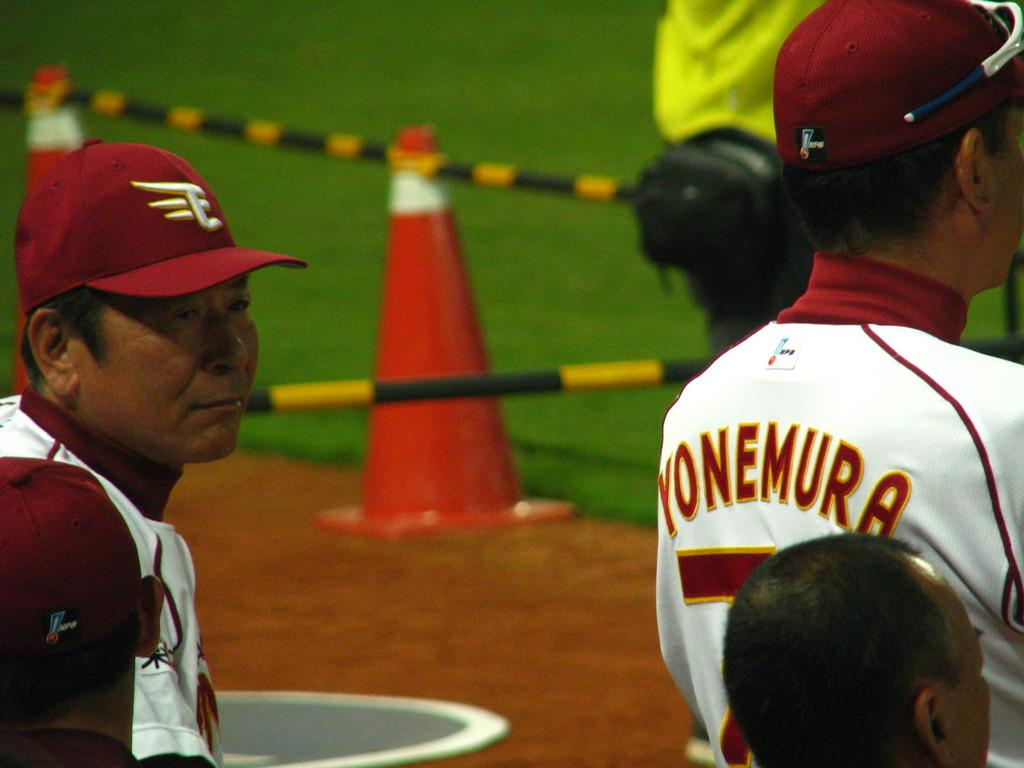<image>
Relay a brief, clear account of the picture shown. Baseball player wearing a jersey which says Yonemura standing on the field. 